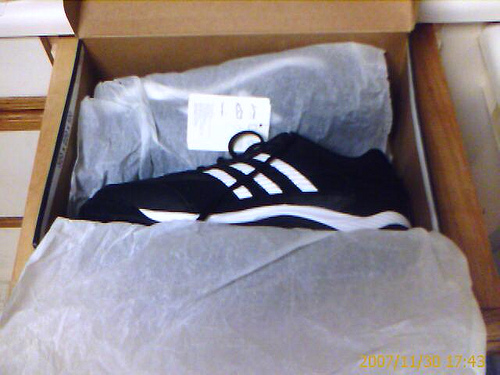<image>
Is the shoe in the box? Yes. The shoe is contained within or inside the box, showing a containment relationship. Is there a shoes next to the box? No. The shoes is not positioned next to the box. They are located in different areas of the scene. 